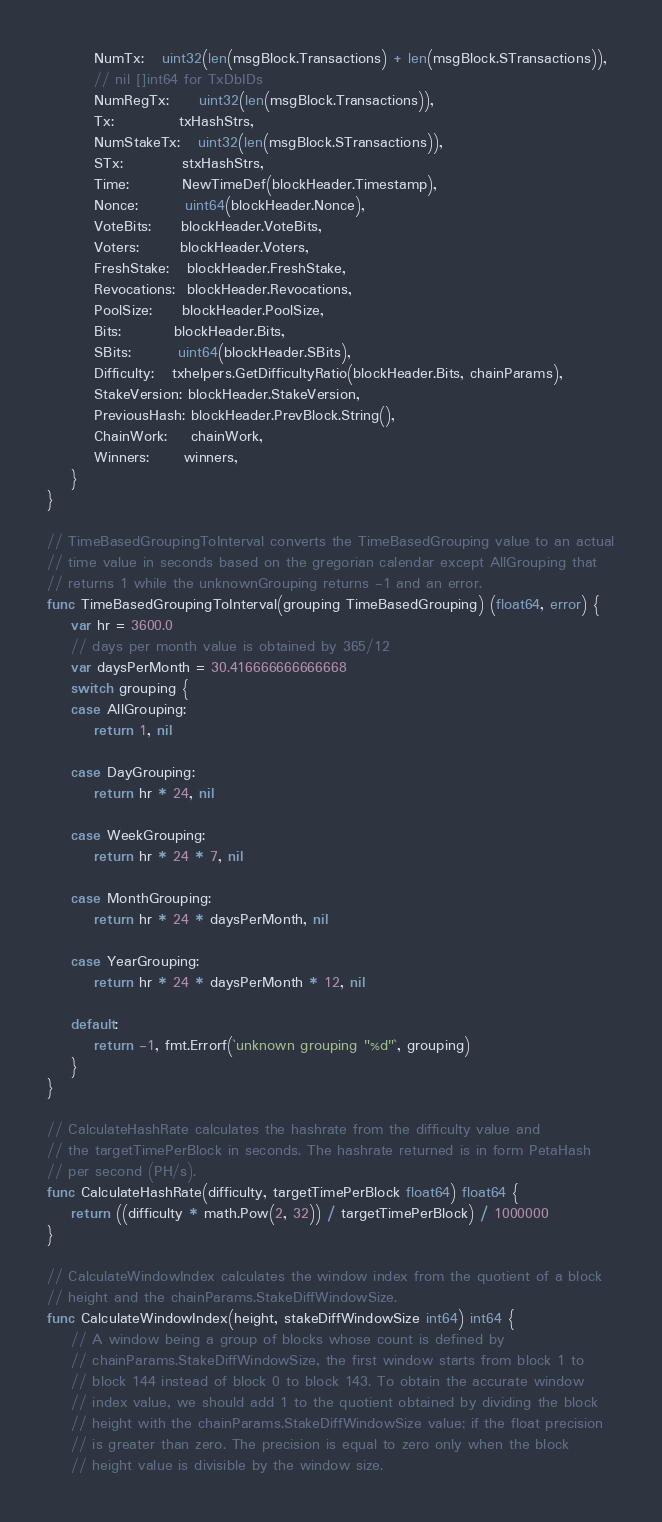Convert code to text. <code><loc_0><loc_0><loc_500><loc_500><_Go_>		NumTx:   uint32(len(msgBlock.Transactions) + len(msgBlock.STransactions)),
		// nil []int64 for TxDbIDs
		NumRegTx:     uint32(len(msgBlock.Transactions)),
		Tx:           txHashStrs,
		NumStakeTx:   uint32(len(msgBlock.STransactions)),
		STx:          stxHashStrs,
		Time:         NewTimeDef(blockHeader.Timestamp),
		Nonce:        uint64(blockHeader.Nonce),
		VoteBits:     blockHeader.VoteBits,
		Voters:       blockHeader.Voters,
		FreshStake:   blockHeader.FreshStake,
		Revocations:  blockHeader.Revocations,
		PoolSize:     blockHeader.PoolSize,
		Bits:         blockHeader.Bits,
		SBits:        uint64(blockHeader.SBits),
		Difficulty:   txhelpers.GetDifficultyRatio(blockHeader.Bits, chainParams),
		StakeVersion: blockHeader.StakeVersion,
		PreviousHash: blockHeader.PrevBlock.String(),
		ChainWork:    chainWork,
		Winners:      winners,
	}
}

// TimeBasedGroupingToInterval converts the TimeBasedGrouping value to an actual
// time value in seconds based on the gregorian calendar except AllGrouping that
// returns 1 while the unknownGrouping returns -1 and an error.
func TimeBasedGroupingToInterval(grouping TimeBasedGrouping) (float64, error) {
	var hr = 3600.0
	// days per month value is obtained by 365/12
	var daysPerMonth = 30.416666666666668
	switch grouping {
	case AllGrouping:
		return 1, nil

	case DayGrouping:
		return hr * 24, nil

	case WeekGrouping:
		return hr * 24 * 7, nil

	case MonthGrouping:
		return hr * 24 * daysPerMonth, nil

	case YearGrouping:
		return hr * 24 * daysPerMonth * 12, nil

	default:
		return -1, fmt.Errorf(`unknown grouping "%d"`, grouping)
	}
}

// CalculateHashRate calculates the hashrate from the difficulty value and
// the targetTimePerBlock in seconds. The hashrate returned is in form PetaHash
// per second (PH/s).
func CalculateHashRate(difficulty, targetTimePerBlock float64) float64 {
	return ((difficulty * math.Pow(2, 32)) / targetTimePerBlock) / 1000000
}

// CalculateWindowIndex calculates the window index from the quotient of a block
// height and the chainParams.StakeDiffWindowSize.
func CalculateWindowIndex(height, stakeDiffWindowSize int64) int64 {
	// A window being a group of blocks whose count is defined by
	// chainParams.StakeDiffWindowSize, the first window starts from block 1 to
	// block 144 instead of block 0 to block 143. To obtain the accurate window
	// index value, we should add 1 to the quotient obtained by dividing the block
	// height with the chainParams.StakeDiffWindowSize value; if the float precision
	// is greater than zero. The precision is equal to zero only when the block
	// height value is divisible by the window size.</code> 